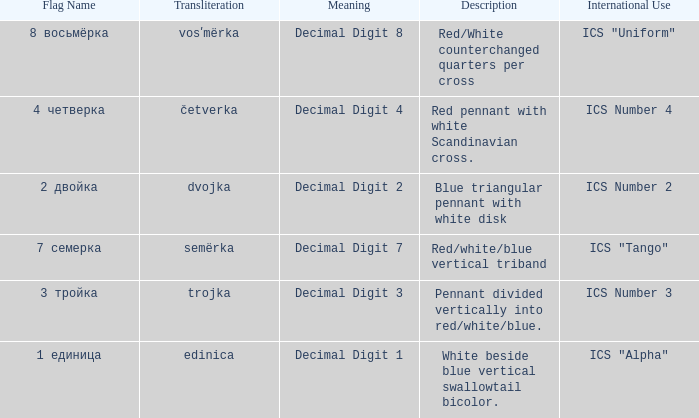What are the meanings of the flag whose name transliterates to semërka? Decimal Digit 7. 